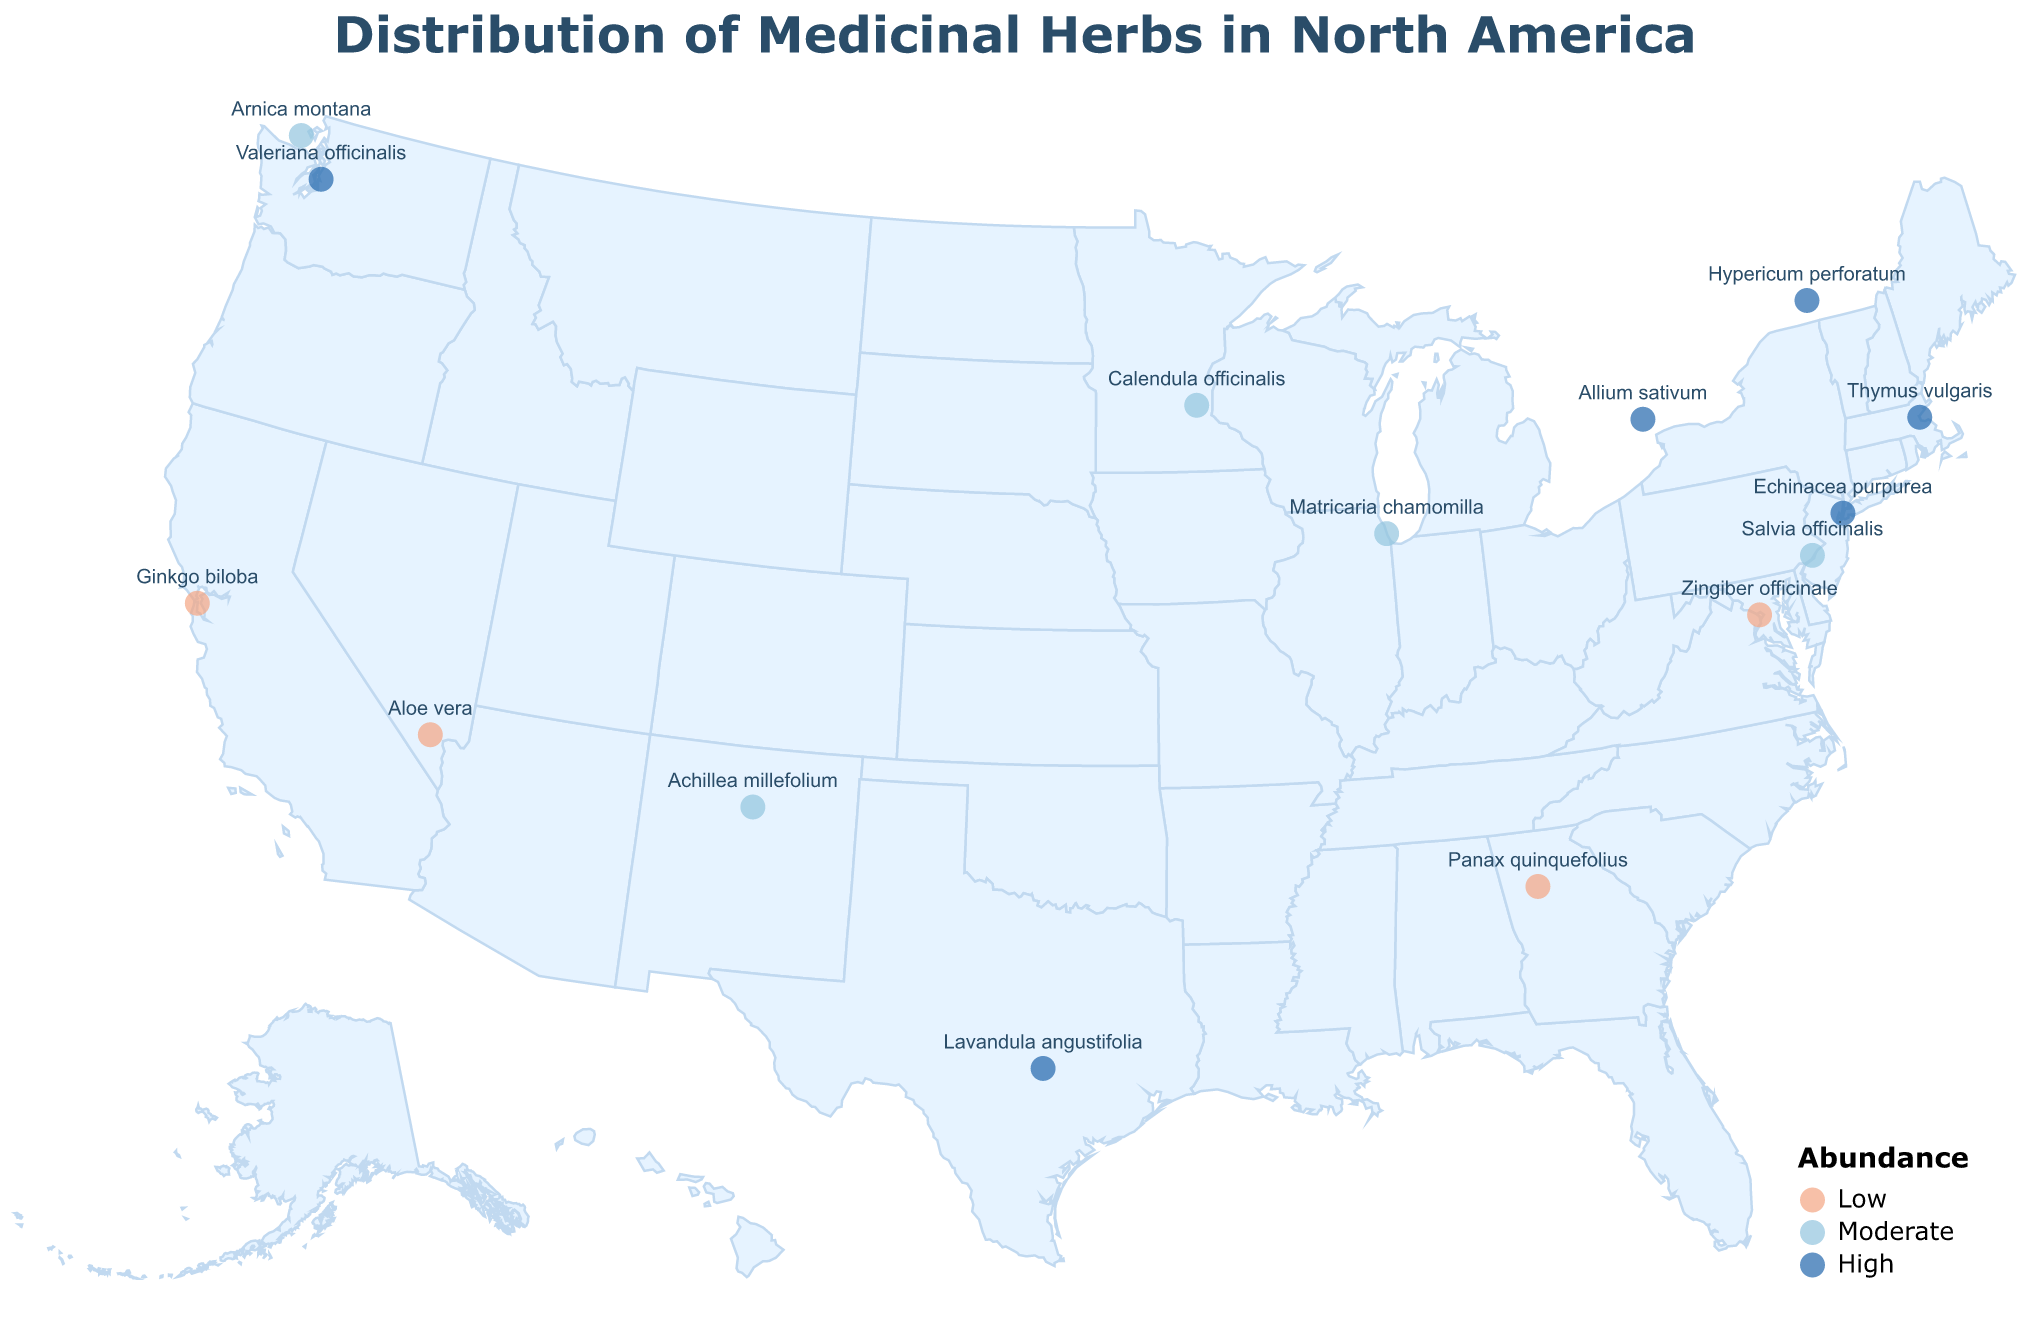Which city has the highest occurrence of herbs? According to the plot, New York (Echinacea purpurea) has the highest abundance classified as 'High'.
Answer: New York Which herb is found in the southernmost location on the map? The herb at the southernmost point on the map is Lavandula angustifolia, located in Austin, Texas.
Answer: Lavandula angustifolia Which herbs have a 'Moderate' abundance classification? Herbs that fall under the 'Moderate' abundance category on the map include Arnica montana, Matricaria chamomilla, Salvia officinalis, Calendula officinalis, and Achillea millefolium.
Answer: Arnica montana, Matricaria chamomilla, Salvia officinalis, Calendula officinalis, Achillea millefolium What is the medicinal use of the herb found in Seattle? According to the plot, Valeriana officinalis, found in Seattle, is used as a sleep aid.
Answer: Sleep aid Which herb is located in geographical proximity to Toronto? The herb located closest to Toronto (slightly northwest) is Allium sativum.
Answer: Allium sativum How many herbs are classified as 'High' in abundance? By inspecting the map, we see there are five herbs classified as 'High' in abundance: Echinacea purpurea, Hypericum perforatum, Valeriana officinalis, Thymus vulgaris, Lavandula angustifolia, and Allium sativum.
Answer: Five Which herb is notably positioned in the westernmost part of the map? Ginkgo biloba, noted for its cognitive function benefits, is positioned in San Francisco, the furthest west on the map.
Answer: Ginkgo biloba What's the collective abundance of herbs located in the eastern part of the United States (specifically New York, Boston, and Philadelphia)? The herbs in the eastern part of the United States (New York - High, Boston - High, Philadelphia - Moderate) collectively reflect two 'High' and one 'Moderate' abundance.
Answer: Two 'High', one 'Moderate' Which herb in the dataset is used for cardiovascular health and where is it located? The herb used for cardiovascular health is Allium sativum, located in Toronto.
Answer: Allium sativum, Toronto Which herbs are located along the west coast of the United States? On the west coast, the herbs are Ginkgo biloba (San Francisco), Valeriana officinalis (Seattle), and Arnica montana (Victoria, Canada).
Answer: Ginkgo biloba, Valeriana officinalis, Arnica montana 